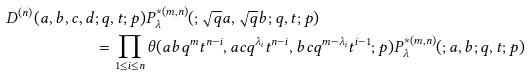Convert formula to latex. <formula><loc_0><loc_0><loc_500><loc_500>D ^ { ( n ) } ( a , b , c , d & ; q , t ; p ) P ^ { * ( m , n ) } _ { \lambda } ( ; \sqrt { q } a , \sqrt { q } b ; q , t ; p ) \\ & = \prod _ { 1 \leq i \leq n } \theta ( a b q ^ { m } t ^ { n - i } , a c q ^ { \lambda _ { i } } t ^ { n - i } , b c q ^ { m - \lambda _ { i } } t ^ { i - 1 } ; p ) P ^ { * ( m , n ) } _ { \lambda } ( ; a , b ; q , t ; p )</formula> 